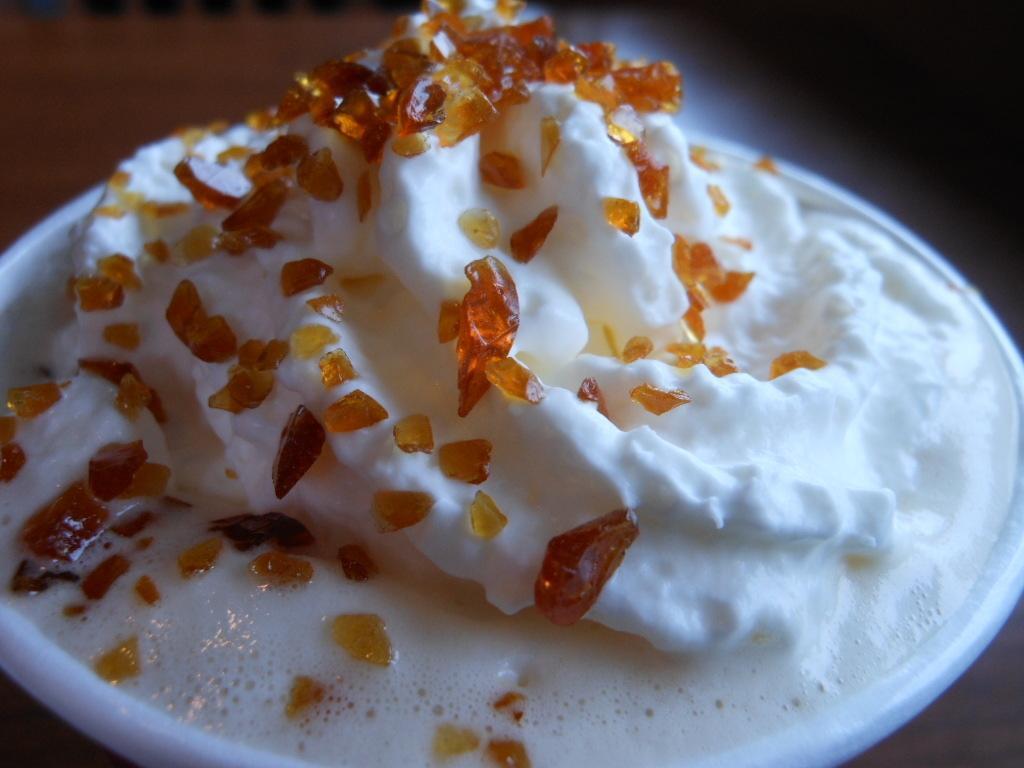Could you give a brief overview of what you see in this image? In this picture I can see the ice cream in a cup. In the back I can see the blur image. 